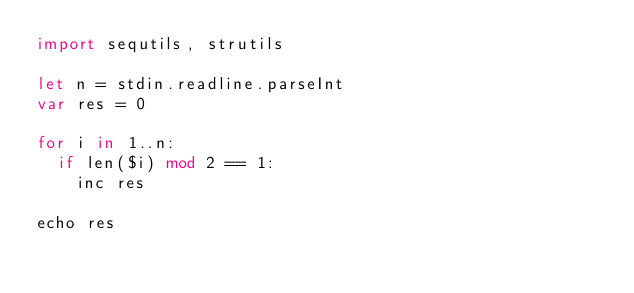<code> <loc_0><loc_0><loc_500><loc_500><_Nim_>import sequtils, strutils

let n = stdin.readline.parseInt
var res = 0

for i in 1..n:
  if len($i) mod 2 == 1:
    inc res

echo res</code> 